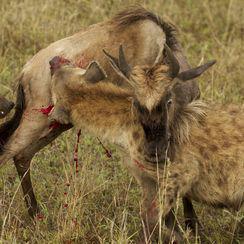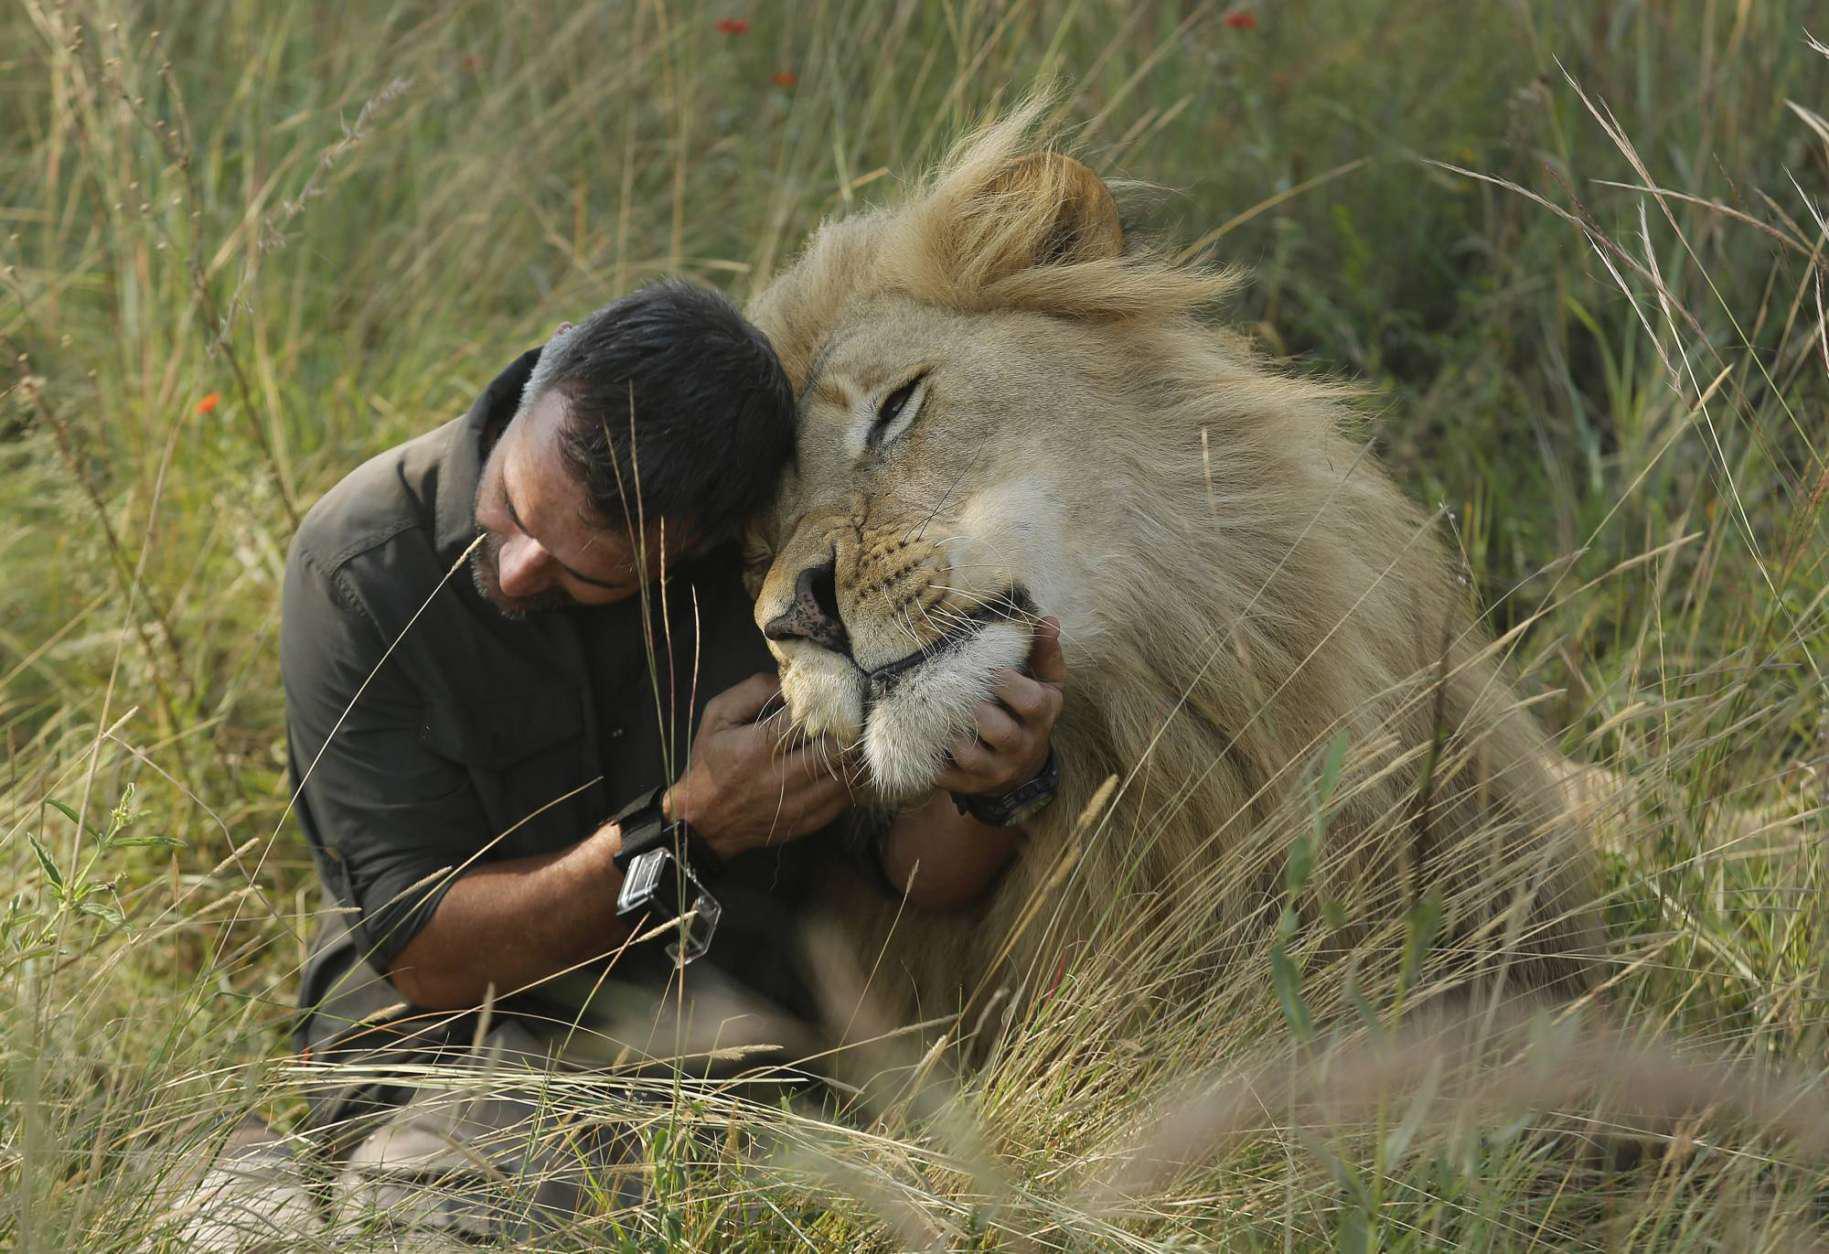The first image is the image on the left, the second image is the image on the right. Examine the images to the left and right. Is the description "In at least one image, a man is hugging a hyena." accurate? Answer yes or no. No. The first image is the image on the left, the second image is the image on the right. Analyze the images presented: Is the assertion "There are two men interacting with one or more large cats." valid? Answer yes or no. No. 